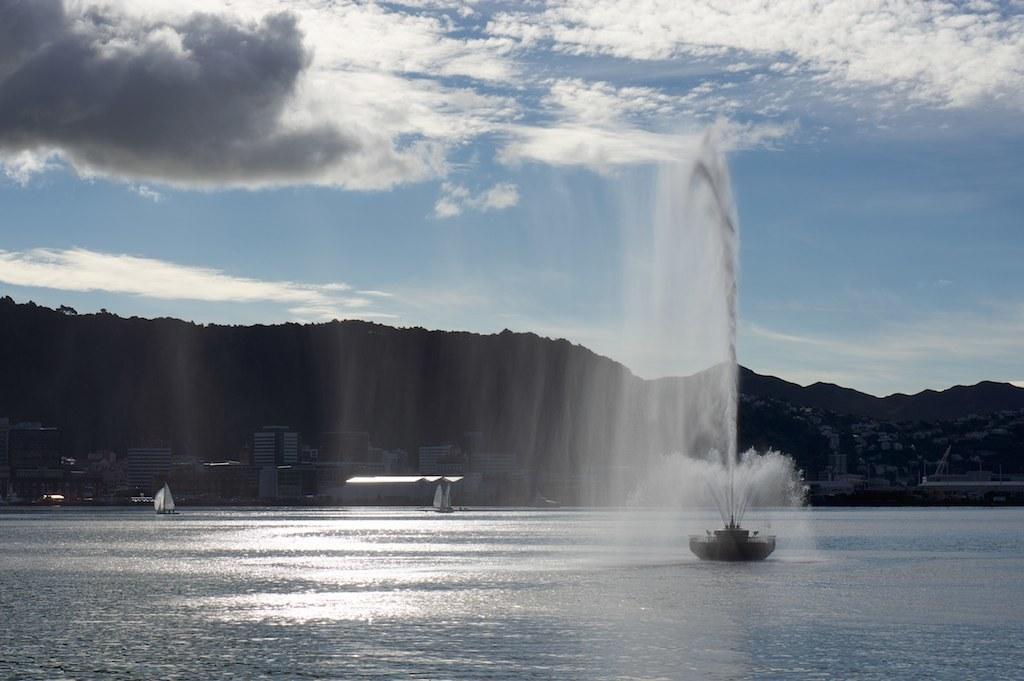Describe this image in one or two sentences. In this picture there are mountains and buildings and trees. In the foreground there are boats on the water and there is a fountain. At the top there is sky and there are clouds. At the bottom there is water. 